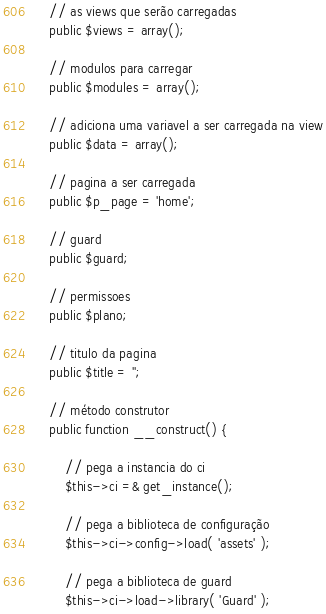Convert code to text. <code><loc_0><loc_0><loc_500><loc_500><_PHP_>
    // as views que serão carregadas
    public $views = array();

    // modulos para carregar
    public $modules = array();

    // adiciona uma variavel a ser carregada na view
    public $data = array();

    // pagina a ser carregada
    public $p_page = 'home';

    // guard
    public $guard;

    // permissoes
    public $plano;

    // titulo da pagina
    public $title = '';

    // método construtor
    public function __construct() {

        // pega a instancia do ci
        $this->ci =& get_instance();

        // pega a biblioteca de configuração
        $this->ci->config->load( 'assets' );

        // pega a biblioteca de guard
        $this->ci->load->library( 'Guard' );</code> 